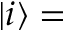Convert formula to latex. <formula><loc_0><loc_0><loc_500><loc_500>| i \rangle =</formula> 